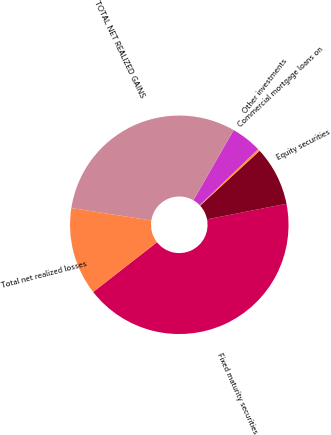<chart> <loc_0><loc_0><loc_500><loc_500><pie_chart><fcel>Fixed maturity securities<fcel>Equity securities<fcel>Commercial mortgage loans on<fcel>Other investments<fcel>TOTAL NET REALIZED GAINS<fcel>Total net realized losses<nl><fcel>42.54%<fcel>8.76%<fcel>0.32%<fcel>4.54%<fcel>30.85%<fcel>12.99%<nl></chart> 